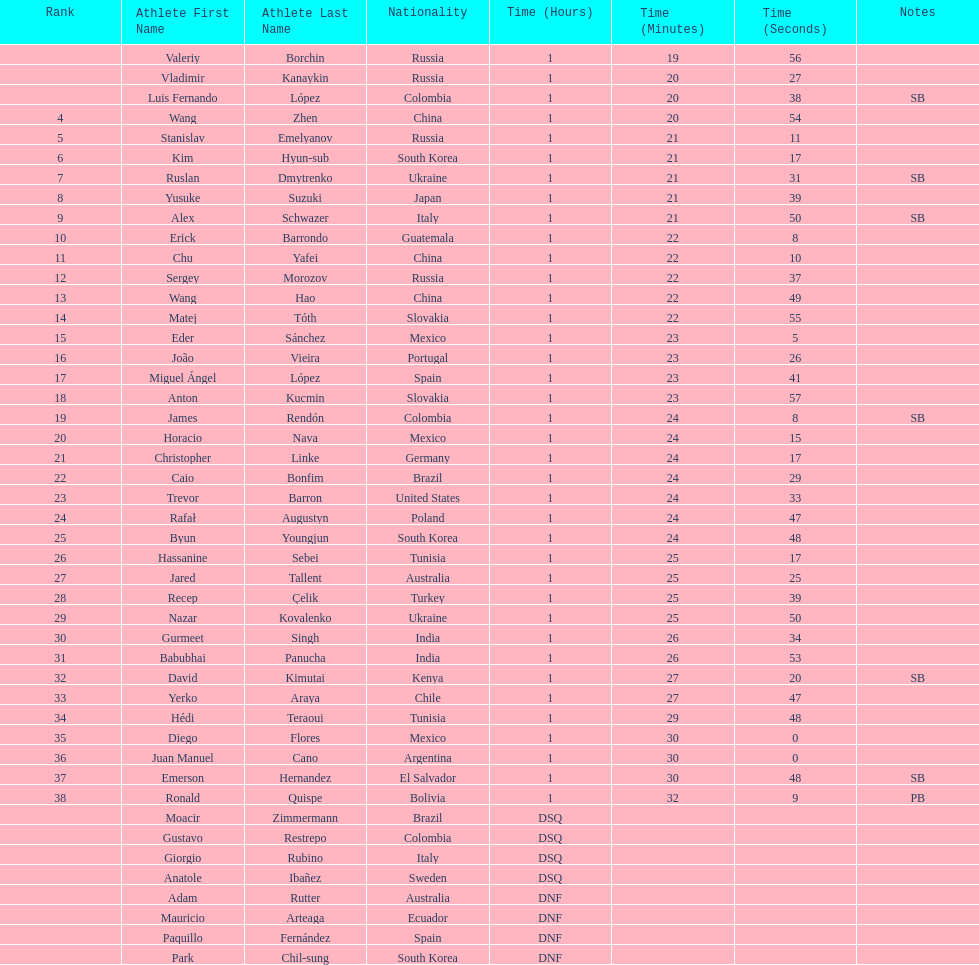How many competitors were from russia? 4. 